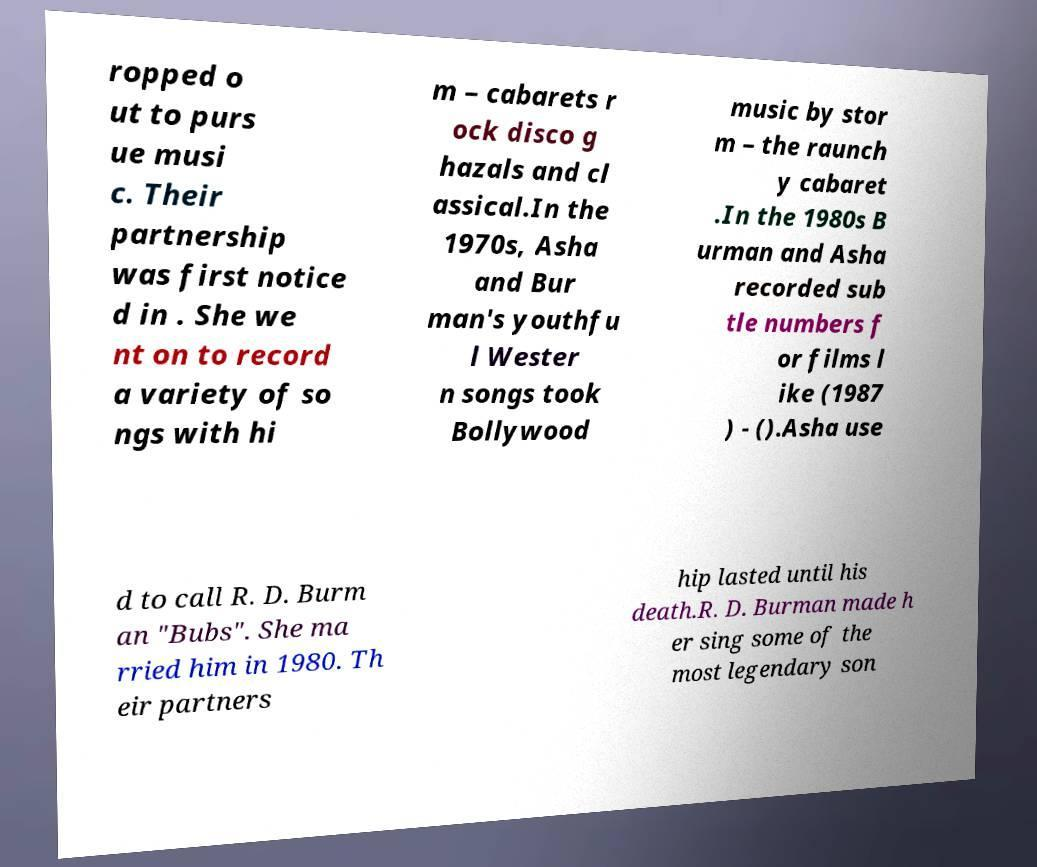I need the written content from this picture converted into text. Can you do that? ropped o ut to purs ue musi c. Their partnership was first notice d in . She we nt on to record a variety of so ngs with hi m – cabarets r ock disco g hazals and cl assical.In the 1970s, Asha and Bur man's youthfu l Wester n songs took Bollywood music by stor m – the raunch y cabaret .In the 1980s B urman and Asha recorded sub tle numbers f or films l ike (1987 ) - ().Asha use d to call R. D. Burm an "Bubs". She ma rried him in 1980. Th eir partners hip lasted until his death.R. D. Burman made h er sing some of the most legendary son 